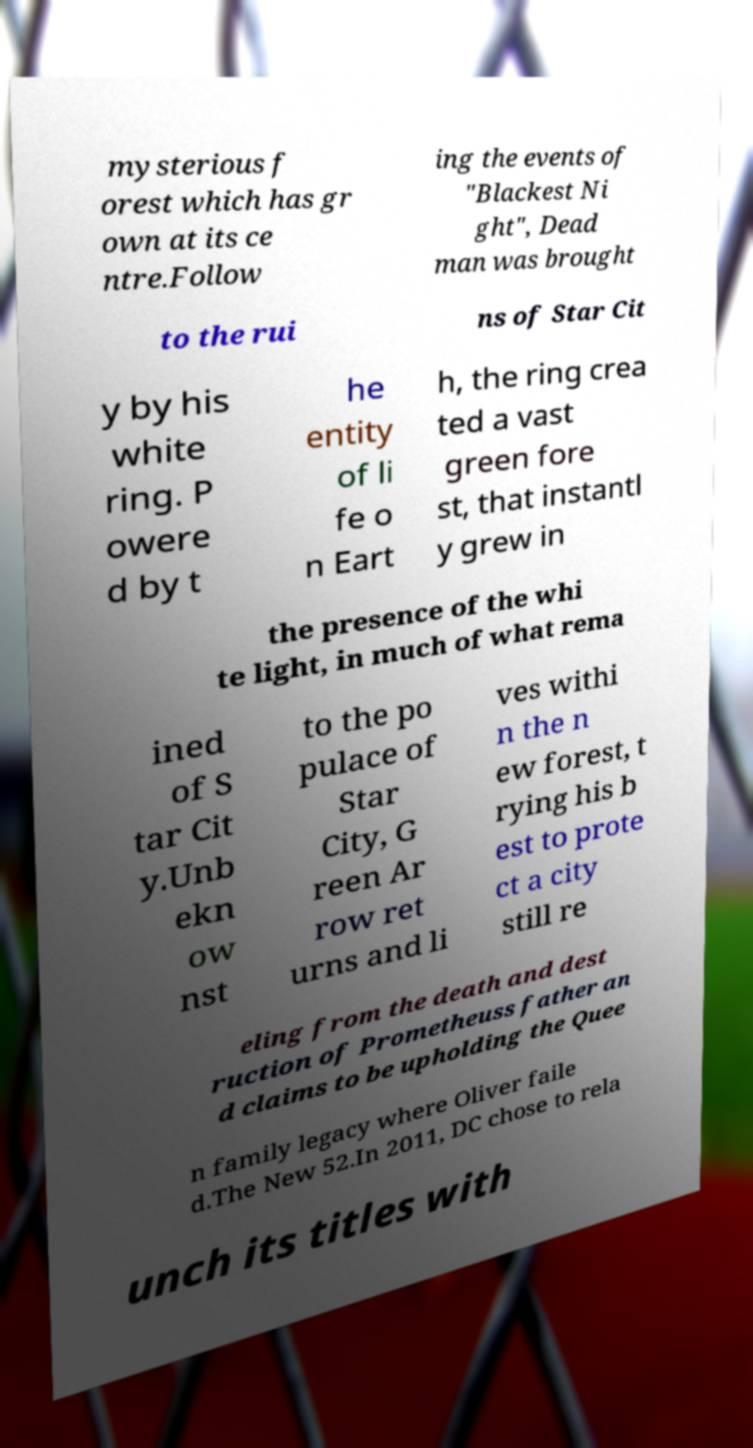Please read and relay the text visible in this image. What does it say? mysterious f orest which has gr own at its ce ntre.Follow ing the events of "Blackest Ni ght", Dead man was brought to the rui ns of Star Cit y by his white ring. P owere d by t he entity of li fe o n Eart h, the ring crea ted a vast green fore st, that instantl y grew in the presence of the whi te light, in much of what rema ined of S tar Cit y.Unb ekn ow nst to the po pulace of Star City, G reen Ar row ret urns and li ves withi n the n ew forest, t rying his b est to prote ct a city still re eling from the death and dest ruction of Prometheuss father an d claims to be upholding the Quee n family legacy where Oliver faile d.The New 52.In 2011, DC chose to rela unch its titles with 